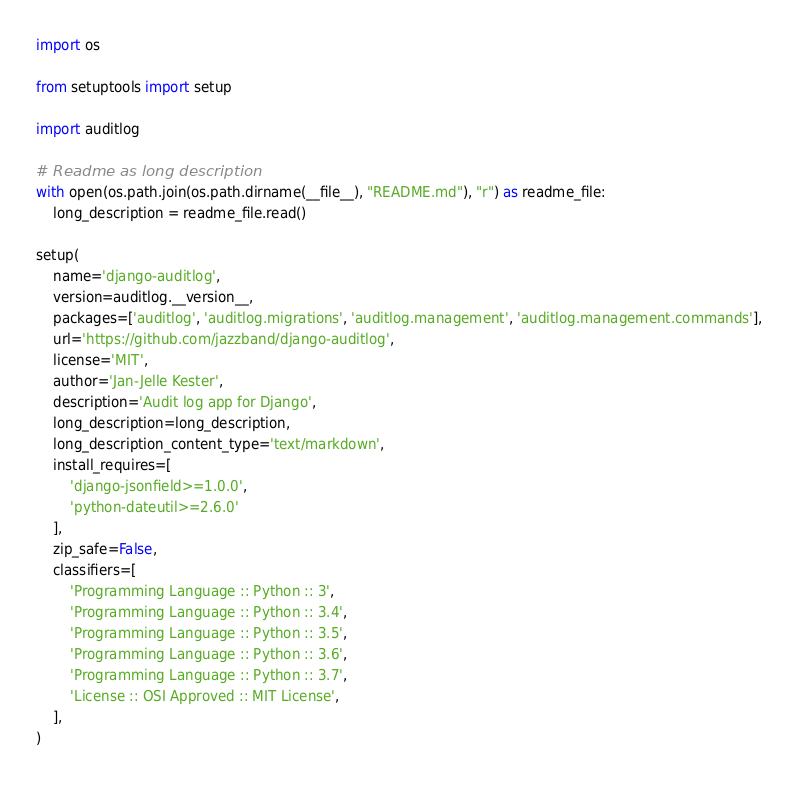Convert code to text. <code><loc_0><loc_0><loc_500><loc_500><_Python_>import os

from setuptools import setup

import auditlog

# Readme as long description
with open(os.path.join(os.path.dirname(__file__), "README.md"), "r") as readme_file:
    long_description = readme_file.read()

setup(
    name='django-auditlog',
    version=auditlog.__version__,
    packages=['auditlog', 'auditlog.migrations', 'auditlog.management', 'auditlog.management.commands'],
    url='https://github.com/jazzband/django-auditlog',
    license='MIT',
    author='Jan-Jelle Kester',
    description='Audit log app for Django',
    long_description=long_description,
    long_description_content_type='text/markdown',
    install_requires=[
        'django-jsonfield>=1.0.0',
        'python-dateutil>=2.6.0'
    ],
    zip_safe=False,
    classifiers=[
        'Programming Language :: Python :: 3',
        'Programming Language :: Python :: 3.4',
        'Programming Language :: Python :: 3.5',
        'Programming Language :: Python :: 3.6',
        'Programming Language :: Python :: 3.7',
        'License :: OSI Approved :: MIT License',
    ],
)
</code> 